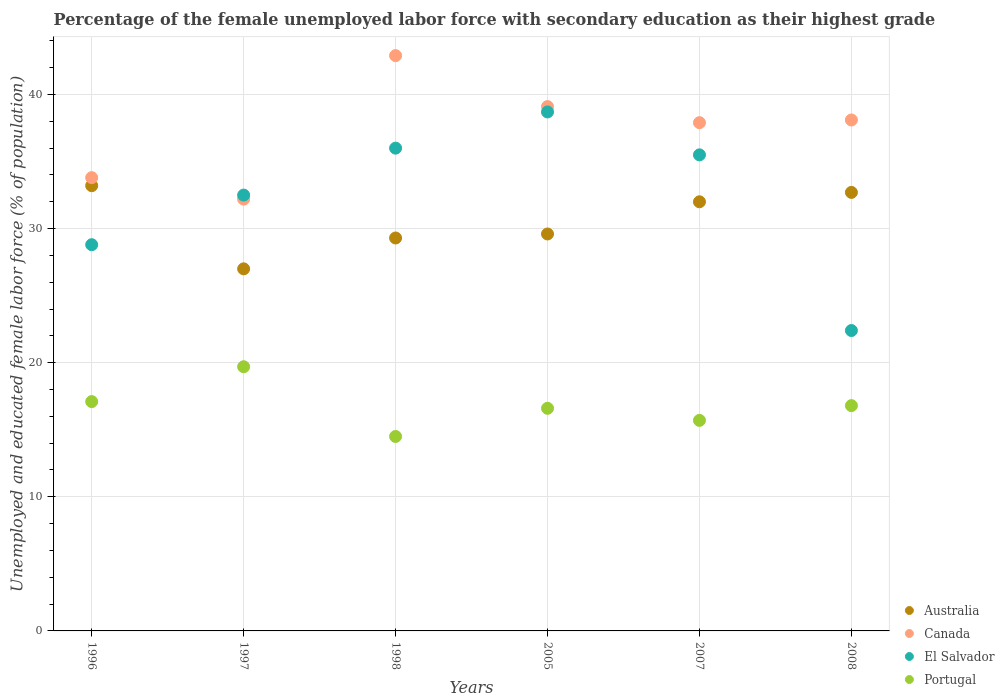How many different coloured dotlines are there?
Your answer should be compact. 4. What is the percentage of the unemployed female labor force with secondary education in Portugal in 2005?
Provide a short and direct response. 16.6. Across all years, what is the maximum percentage of the unemployed female labor force with secondary education in Canada?
Your response must be concise. 42.9. Across all years, what is the minimum percentage of the unemployed female labor force with secondary education in Portugal?
Keep it short and to the point. 14.5. In which year was the percentage of the unemployed female labor force with secondary education in El Salvador maximum?
Offer a very short reply. 2005. In which year was the percentage of the unemployed female labor force with secondary education in Australia minimum?
Ensure brevity in your answer.  1997. What is the total percentage of the unemployed female labor force with secondary education in Portugal in the graph?
Keep it short and to the point. 100.4. What is the difference between the percentage of the unemployed female labor force with secondary education in Australia in 1997 and that in 1998?
Offer a very short reply. -2.3. What is the difference between the percentage of the unemployed female labor force with secondary education in Canada in 1998 and the percentage of the unemployed female labor force with secondary education in Portugal in 2007?
Your answer should be compact. 27.2. What is the average percentage of the unemployed female labor force with secondary education in Australia per year?
Make the answer very short. 30.63. In the year 1996, what is the difference between the percentage of the unemployed female labor force with secondary education in Australia and percentage of the unemployed female labor force with secondary education in El Salvador?
Ensure brevity in your answer.  4.4. In how many years, is the percentage of the unemployed female labor force with secondary education in Australia greater than 14 %?
Keep it short and to the point. 6. What is the ratio of the percentage of the unemployed female labor force with secondary education in El Salvador in 1997 to that in 2005?
Give a very brief answer. 0.84. Is the percentage of the unemployed female labor force with secondary education in Australia in 1998 less than that in 2005?
Your response must be concise. Yes. What is the difference between the highest and the second highest percentage of the unemployed female labor force with secondary education in El Salvador?
Give a very brief answer. 2.7. What is the difference between the highest and the lowest percentage of the unemployed female labor force with secondary education in El Salvador?
Make the answer very short. 16.3. Is the sum of the percentage of the unemployed female labor force with secondary education in Canada in 1997 and 2007 greater than the maximum percentage of the unemployed female labor force with secondary education in Portugal across all years?
Your response must be concise. Yes. Is it the case that in every year, the sum of the percentage of the unemployed female labor force with secondary education in Portugal and percentage of the unemployed female labor force with secondary education in Australia  is greater than the sum of percentage of the unemployed female labor force with secondary education in Canada and percentage of the unemployed female labor force with secondary education in El Salvador?
Provide a short and direct response. No. Is it the case that in every year, the sum of the percentage of the unemployed female labor force with secondary education in Australia and percentage of the unemployed female labor force with secondary education in El Salvador  is greater than the percentage of the unemployed female labor force with secondary education in Canada?
Make the answer very short. Yes. What is the difference between two consecutive major ticks on the Y-axis?
Provide a short and direct response. 10. Does the graph contain any zero values?
Your answer should be compact. No. Does the graph contain grids?
Provide a succinct answer. Yes. Where does the legend appear in the graph?
Your answer should be compact. Bottom right. How many legend labels are there?
Your answer should be compact. 4. What is the title of the graph?
Keep it short and to the point. Percentage of the female unemployed labor force with secondary education as their highest grade. Does "Faeroe Islands" appear as one of the legend labels in the graph?
Keep it short and to the point. No. What is the label or title of the X-axis?
Your answer should be very brief. Years. What is the label or title of the Y-axis?
Your answer should be very brief. Unemployed and educated female labor force (% of population). What is the Unemployed and educated female labor force (% of population) in Australia in 1996?
Your answer should be compact. 33.2. What is the Unemployed and educated female labor force (% of population) in Canada in 1996?
Offer a terse response. 33.8. What is the Unemployed and educated female labor force (% of population) in El Salvador in 1996?
Make the answer very short. 28.8. What is the Unemployed and educated female labor force (% of population) in Portugal in 1996?
Your answer should be very brief. 17.1. What is the Unemployed and educated female labor force (% of population) in Australia in 1997?
Offer a very short reply. 27. What is the Unemployed and educated female labor force (% of population) of Canada in 1997?
Your answer should be very brief. 32.2. What is the Unemployed and educated female labor force (% of population) in El Salvador in 1997?
Make the answer very short. 32.5. What is the Unemployed and educated female labor force (% of population) in Portugal in 1997?
Your response must be concise. 19.7. What is the Unemployed and educated female labor force (% of population) in Australia in 1998?
Provide a succinct answer. 29.3. What is the Unemployed and educated female labor force (% of population) of Canada in 1998?
Your answer should be very brief. 42.9. What is the Unemployed and educated female labor force (% of population) in El Salvador in 1998?
Offer a terse response. 36. What is the Unemployed and educated female labor force (% of population) in Australia in 2005?
Your answer should be very brief. 29.6. What is the Unemployed and educated female labor force (% of population) of Canada in 2005?
Keep it short and to the point. 39.1. What is the Unemployed and educated female labor force (% of population) in El Salvador in 2005?
Provide a short and direct response. 38.7. What is the Unemployed and educated female labor force (% of population) of Portugal in 2005?
Offer a very short reply. 16.6. What is the Unemployed and educated female labor force (% of population) in Canada in 2007?
Make the answer very short. 37.9. What is the Unemployed and educated female labor force (% of population) in El Salvador in 2007?
Your answer should be compact. 35.5. What is the Unemployed and educated female labor force (% of population) in Portugal in 2007?
Ensure brevity in your answer.  15.7. What is the Unemployed and educated female labor force (% of population) of Australia in 2008?
Your answer should be compact. 32.7. What is the Unemployed and educated female labor force (% of population) in Canada in 2008?
Make the answer very short. 38.1. What is the Unemployed and educated female labor force (% of population) in El Salvador in 2008?
Keep it short and to the point. 22.4. What is the Unemployed and educated female labor force (% of population) in Portugal in 2008?
Give a very brief answer. 16.8. Across all years, what is the maximum Unemployed and educated female labor force (% of population) of Australia?
Your response must be concise. 33.2. Across all years, what is the maximum Unemployed and educated female labor force (% of population) in Canada?
Offer a very short reply. 42.9. Across all years, what is the maximum Unemployed and educated female labor force (% of population) in El Salvador?
Ensure brevity in your answer.  38.7. Across all years, what is the maximum Unemployed and educated female labor force (% of population) of Portugal?
Your answer should be compact. 19.7. Across all years, what is the minimum Unemployed and educated female labor force (% of population) in Australia?
Offer a very short reply. 27. Across all years, what is the minimum Unemployed and educated female labor force (% of population) of Canada?
Your response must be concise. 32.2. Across all years, what is the minimum Unemployed and educated female labor force (% of population) of El Salvador?
Your response must be concise. 22.4. What is the total Unemployed and educated female labor force (% of population) of Australia in the graph?
Ensure brevity in your answer.  183.8. What is the total Unemployed and educated female labor force (% of population) of Canada in the graph?
Your answer should be very brief. 224. What is the total Unemployed and educated female labor force (% of population) of El Salvador in the graph?
Make the answer very short. 193.9. What is the total Unemployed and educated female labor force (% of population) in Portugal in the graph?
Provide a succinct answer. 100.4. What is the difference between the Unemployed and educated female labor force (% of population) of Australia in 1996 and that in 1997?
Offer a terse response. 6.2. What is the difference between the Unemployed and educated female labor force (% of population) in El Salvador in 1996 and that in 1997?
Your response must be concise. -3.7. What is the difference between the Unemployed and educated female labor force (% of population) in Portugal in 1996 and that in 1997?
Make the answer very short. -2.6. What is the difference between the Unemployed and educated female labor force (% of population) of Canada in 1996 and that in 1998?
Keep it short and to the point. -9.1. What is the difference between the Unemployed and educated female labor force (% of population) of El Salvador in 1996 and that in 1998?
Provide a succinct answer. -7.2. What is the difference between the Unemployed and educated female labor force (% of population) of Australia in 1996 and that in 2005?
Keep it short and to the point. 3.6. What is the difference between the Unemployed and educated female labor force (% of population) in El Salvador in 1996 and that in 2005?
Give a very brief answer. -9.9. What is the difference between the Unemployed and educated female labor force (% of population) of Australia in 1996 and that in 2007?
Offer a terse response. 1.2. What is the difference between the Unemployed and educated female labor force (% of population) in Canada in 1996 and that in 2007?
Offer a very short reply. -4.1. What is the difference between the Unemployed and educated female labor force (% of population) of El Salvador in 1996 and that in 2007?
Your response must be concise. -6.7. What is the difference between the Unemployed and educated female labor force (% of population) of Australia in 1996 and that in 2008?
Your response must be concise. 0.5. What is the difference between the Unemployed and educated female labor force (% of population) of Canada in 1996 and that in 2008?
Your answer should be very brief. -4.3. What is the difference between the Unemployed and educated female labor force (% of population) in Australia in 1997 and that in 1998?
Your answer should be very brief. -2.3. What is the difference between the Unemployed and educated female labor force (% of population) of Canada in 1997 and that in 1998?
Your answer should be very brief. -10.7. What is the difference between the Unemployed and educated female labor force (% of population) of Australia in 1997 and that in 2005?
Keep it short and to the point. -2.6. What is the difference between the Unemployed and educated female labor force (% of population) of Canada in 1997 and that in 2005?
Ensure brevity in your answer.  -6.9. What is the difference between the Unemployed and educated female labor force (% of population) of Australia in 1997 and that in 2007?
Make the answer very short. -5. What is the difference between the Unemployed and educated female labor force (% of population) of Canada in 1997 and that in 2007?
Make the answer very short. -5.7. What is the difference between the Unemployed and educated female labor force (% of population) of Portugal in 1997 and that in 2007?
Keep it short and to the point. 4. What is the difference between the Unemployed and educated female labor force (% of population) in El Salvador in 1997 and that in 2008?
Your answer should be very brief. 10.1. What is the difference between the Unemployed and educated female labor force (% of population) of Canada in 1998 and that in 2005?
Keep it short and to the point. 3.8. What is the difference between the Unemployed and educated female labor force (% of population) of El Salvador in 1998 and that in 2005?
Ensure brevity in your answer.  -2.7. What is the difference between the Unemployed and educated female labor force (% of population) of Portugal in 1998 and that in 2005?
Your response must be concise. -2.1. What is the difference between the Unemployed and educated female labor force (% of population) of Australia in 1998 and that in 2008?
Keep it short and to the point. -3.4. What is the difference between the Unemployed and educated female labor force (% of population) in Portugal in 1998 and that in 2008?
Make the answer very short. -2.3. What is the difference between the Unemployed and educated female labor force (% of population) in Australia in 2005 and that in 2007?
Your answer should be very brief. -2.4. What is the difference between the Unemployed and educated female labor force (% of population) of El Salvador in 2005 and that in 2007?
Give a very brief answer. 3.2. What is the difference between the Unemployed and educated female labor force (% of population) in Australia in 2005 and that in 2008?
Your answer should be compact. -3.1. What is the difference between the Unemployed and educated female labor force (% of population) of Canada in 2005 and that in 2008?
Keep it short and to the point. 1. What is the difference between the Unemployed and educated female labor force (% of population) of El Salvador in 2005 and that in 2008?
Make the answer very short. 16.3. What is the difference between the Unemployed and educated female labor force (% of population) of Australia in 2007 and that in 2008?
Provide a short and direct response. -0.7. What is the difference between the Unemployed and educated female labor force (% of population) of Australia in 1996 and the Unemployed and educated female labor force (% of population) of Canada in 1997?
Ensure brevity in your answer.  1. What is the difference between the Unemployed and educated female labor force (% of population) in Australia in 1996 and the Unemployed and educated female labor force (% of population) in El Salvador in 1997?
Provide a short and direct response. 0.7. What is the difference between the Unemployed and educated female labor force (% of population) in Australia in 1996 and the Unemployed and educated female labor force (% of population) in Portugal in 1997?
Provide a succinct answer. 13.5. What is the difference between the Unemployed and educated female labor force (% of population) of Canada in 1996 and the Unemployed and educated female labor force (% of population) of El Salvador in 1997?
Offer a terse response. 1.3. What is the difference between the Unemployed and educated female labor force (% of population) of Canada in 1996 and the Unemployed and educated female labor force (% of population) of Portugal in 1997?
Give a very brief answer. 14.1. What is the difference between the Unemployed and educated female labor force (% of population) of Australia in 1996 and the Unemployed and educated female labor force (% of population) of Canada in 1998?
Provide a short and direct response. -9.7. What is the difference between the Unemployed and educated female labor force (% of population) of Australia in 1996 and the Unemployed and educated female labor force (% of population) of El Salvador in 1998?
Give a very brief answer. -2.8. What is the difference between the Unemployed and educated female labor force (% of population) in Canada in 1996 and the Unemployed and educated female labor force (% of population) in El Salvador in 1998?
Provide a short and direct response. -2.2. What is the difference between the Unemployed and educated female labor force (% of population) in Canada in 1996 and the Unemployed and educated female labor force (% of population) in Portugal in 1998?
Provide a short and direct response. 19.3. What is the difference between the Unemployed and educated female labor force (% of population) in Australia in 1996 and the Unemployed and educated female labor force (% of population) in Canada in 2005?
Offer a terse response. -5.9. What is the difference between the Unemployed and educated female labor force (% of population) in El Salvador in 1996 and the Unemployed and educated female labor force (% of population) in Portugal in 2005?
Ensure brevity in your answer.  12.2. What is the difference between the Unemployed and educated female labor force (% of population) of Australia in 1996 and the Unemployed and educated female labor force (% of population) of Canada in 2007?
Your answer should be compact. -4.7. What is the difference between the Unemployed and educated female labor force (% of population) in Canada in 1996 and the Unemployed and educated female labor force (% of population) in El Salvador in 2007?
Provide a short and direct response. -1.7. What is the difference between the Unemployed and educated female labor force (% of population) of Canada in 1996 and the Unemployed and educated female labor force (% of population) of Portugal in 2007?
Provide a succinct answer. 18.1. What is the difference between the Unemployed and educated female labor force (% of population) of Australia in 1996 and the Unemployed and educated female labor force (% of population) of Canada in 2008?
Offer a very short reply. -4.9. What is the difference between the Unemployed and educated female labor force (% of population) in Australia in 1996 and the Unemployed and educated female labor force (% of population) in Portugal in 2008?
Your response must be concise. 16.4. What is the difference between the Unemployed and educated female labor force (% of population) of Canada in 1996 and the Unemployed and educated female labor force (% of population) of El Salvador in 2008?
Your answer should be very brief. 11.4. What is the difference between the Unemployed and educated female labor force (% of population) of Canada in 1996 and the Unemployed and educated female labor force (% of population) of Portugal in 2008?
Offer a terse response. 17. What is the difference between the Unemployed and educated female labor force (% of population) of Australia in 1997 and the Unemployed and educated female labor force (% of population) of Canada in 1998?
Provide a short and direct response. -15.9. What is the difference between the Unemployed and educated female labor force (% of population) of Canada in 1997 and the Unemployed and educated female labor force (% of population) of El Salvador in 1998?
Provide a succinct answer. -3.8. What is the difference between the Unemployed and educated female labor force (% of population) of Canada in 1997 and the Unemployed and educated female labor force (% of population) of Portugal in 1998?
Provide a short and direct response. 17.7. What is the difference between the Unemployed and educated female labor force (% of population) of Australia in 1997 and the Unemployed and educated female labor force (% of population) of Canada in 2005?
Keep it short and to the point. -12.1. What is the difference between the Unemployed and educated female labor force (% of population) of Australia in 1997 and the Unemployed and educated female labor force (% of population) of Portugal in 2005?
Keep it short and to the point. 10.4. What is the difference between the Unemployed and educated female labor force (% of population) of El Salvador in 1997 and the Unemployed and educated female labor force (% of population) of Portugal in 2005?
Provide a succinct answer. 15.9. What is the difference between the Unemployed and educated female labor force (% of population) of Australia in 1997 and the Unemployed and educated female labor force (% of population) of Portugal in 2007?
Your answer should be compact. 11.3. What is the difference between the Unemployed and educated female labor force (% of population) in Canada in 1997 and the Unemployed and educated female labor force (% of population) in El Salvador in 2007?
Provide a short and direct response. -3.3. What is the difference between the Unemployed and educated female labor force (% of population) in Canada in 1997 and the Unemployed and educated female labor force (% of population) in Portugal in 2007?
Keep it short and to the point. 16.5. What is the difference between the Unemployed and educated female labor force (% of population) of El Salvador in 1997 and the Unemployed and educated female labor force (% of population) of Portugal in 2007?
Your answer should be very brief. 16.8. What is the difference between the Unemployed and educated female labor force (% of population) of Australia in 1997 and the Unemployed and educated female labor force (% of population) of El Salvador in 2008?
Provide a succinct answer. 4.6. What is the difference between the Unemployed and educated female labor force (% of population) in Canada in 1997 and the Unemployed and educated female labor force (% of population) in El Salvador in 2008?
Offer a very short reply. 9.8. What is the difference between the Unemployed and educated female labor force (% of population) in Canada in 1997 and the Unemployed and educated female labor force (% of population) in Portugal in 2008?
Give a very brief answer. 15.4. What is the difference between the Unemployed and educated female labor force (% of population) in El Salvador in 1997 and the Unemployed and educated female labor force (% of population) in Portugal in 2008?
Offer a terse response. 15.7. What is the difference between the Unemployed and educated female labor force (% of population) in Australia in 1998 and the Unemployed and educated female labor force (% of population) in Portugal in 2005?
Keep it short and to the point. 12.7. What is the difference between the Unemployed and educated female labor force (% of population) in Canada in 1998 and the Unemployed and educated female labor force (% of population) in Portugal in 2005?
Your answer should be very brief. 26.3. What is the difference between the Unemployed and educated female labor force (% of population) in El Salvador in 1998 and the Unemployed and educated female labor force (% of population) in Portugal in 2005?
Your response must be concise. 19.4. What is the difference between the Unemployed and educated female labor force (% of population) in Australia in 1998 and the Unemployed and educated female labor force (% of population) in Canada in 2007?
Offer a very short reply. -8.6. What is the difference between the Unemployed and educated female labor force (% of population) in Canada in 1998 and the Unemployed and educated female labor force (% of population) in El Salvador in 2007?
Offer a terse response. 7.4. What is the difference between the Unemployed and educated female labor force (% of population) of Canada in 1998 and the Unemployed and educated female labor force (% of population) of Portugal in 2007?
Ensure brevity in your answer.  27.2. What is the difference between the Unemployed and educated female labor force (% of population) in El Salvador in 1998 and the Unemployed and educated female labor force (% of population) in Portugal in 2007?
Make the answer very short. 20.3. What is the difference between the Unemployed and educated female labor force (% of population) in Canada in 1998 and the Unemployed and educated female labor force (% of population) in Portugal in 2008?
Provide a succinct answer. 26.1. What is the difference between the Unemployed and educated female labor force (% of population) in El Salvador in 1998 and the Unemployed and educated female labor force (% of population) in Portugal in 2008?
Provide a succinct answer. 19.2. What is the difference between the Unemployed and educated female labor force (% of population) in Australia in 2005 and the Unemployed and educated female labor force (% of population) in El Salvador in 2007?
Keep it short and to the point. -5.9. What is the difference between the Unemployed and educated female labor force (% of population) of Canada in 2005 and the Unemployed and educated female labor force (% of population) of Portugal in 2007?
Offer a terse response. 23.4. What is the difference between the Unemployed and educated female labor force (% of population) of Australia in 2005 and the Unemployed and educated female labor force (% of population) of Canada in 2008?
Offer a terse response. -8.5. What is the difference between the Unemployed and educated female labor force (% of population) in Canada in 2005 and the Unemployed and educated female labor force (% of population) in El Salvador in 2008?
Provide a succinct answer. 16.7. What is the difference between the Unemployed and educated female labor force (% of population) in Canada in 2005 and the Unemployed and educated female labor force (% of population) in Portugal in 2008?
Ensure brevity in your answer.  22.3. What is the difference between the Unemployed and educated female labor force (% of population) of El Salvador in 2005 and the Unemployed and educated female labor force (% of population) of Portugal in 2008?
Provide a succinct answer. 21.9. What is the difference between the Unemployed and educated female labor force (% of population) of Australia in 2007 and the Unemployed and educated female labor force (% of population) of Portugal in 2008?
Make the answer very short. 15.2. What is the difference between the Unemployed and educated female labor force (% of population) of Canada in 2007 and the Unemployed and educated female labor force (% of population) of Portugal in 2008?
Your answer should be very brief. 21.1. What is the average Unemployed and educated female labor force (% of population) in Australia per year?
Your answer should be very brief. 30.63. What is the average Unemployed and educated female labor force (% of population) in Canada per year?
Offer a terse response. 37.33. What is the average Unemployed and educated female labor force (% of population) in El Salvador per year?
Offer a terse response. 32.32. What is the average Unemployed and educated female labor force (% of population) of Portugal per year?
Offer a very short reply. 16.73. In the year 1996, what is the difference between the Unemployed and educated female labor force (% of population) in Australia and Unemployed and educated female labor force (% of population) in Canada?
Keep it short and to the point. -0.6. In the year 1996, what is the difference between the Unemployed and educated female labor force (% of population) in El Salvador and Unemployed and educated female labor force (% of population) in Portugal?
Provide a succinct answer. 11.7. In the year 1997, what is the difference between the Unemployed and educated female labor force (% of population) of Australia and Unemployed and educated female labor force (% of population) of Canada?
Offer a very short reply. -5.2. In the year 1997, what is the difference between the Unemployed and educated female labor force (% of population) in Australia and Unemployed and educated female labor force (% of population) in Portugal?
Provide a succinct answer. 7.3. In the year 1997, what is the difference between the Unemployed and educated female labor force (% of population) in Canada and Unemployed and educated female labor force (% of population) in El Salvador?
Your answer should be compact. -0.3. In the year 1997, what is the difference between the Unemployed and educated female labor force (% of population) of Canada and Unemployed and educated female labor force (% of population) of Portugal?
Your response must be concise. 12.5. In the year 1998, what is the difference between the Unemployed and educated female labor force (% of population) of Australia and Unemployed and educated female labor force (% of population) of El Salvador?
Provide a short and direct response. -6.7. In the year 1998, what is the difference between the Unemployed and educated female labor force (% of population) of Canada and Unemployed and educated female labor force (% of population) of El Salvador?
Your response must be concise. 6.9. In the year 1998, what is the difference between the Unemployed and educated female labor force (% of population) in Canada and Unemployed and educated female labor force (% of population) in Portugal?
Offer a terse response. 28.4. In the year 2005, what is the difference between the Unemployed and educated female labor force (% of population) of Australia and Unemployed and educated female labor force (% of population) of Portugal?
Offer a terse response. 13. In the year 2005, what is the difference between the Unemployed and educated female labor force (% of population) of Canada and Unemployed and educated female labor force (% of population) of Portugal?
Your answer should be very brief. 22.5. In the year 2005, what is the difference between the Unemployed and educated female labor force (% of population) in El Salvador and Unemployed and educated female labor force (% of population) in Portugal?
Keep it short and to the point. 22.1. In the year 2007, what is the difference between the Unemployed and educated female labor force (% of population) of Australia and Unemployed and educated female labor force (% of population) of Canada?
Make the answer very short. -5.9. In the year 2007, what is the difference between the Unemployed and educated female labor force (% of population) in Canada and Unemployed and educated female labor force (% of population) in Portugal?
Your answer should be compact. 22.2. In the year 2007, what is the difference between the Unemployed and educated female labor force (% of population) of El Salvador and Unemployed and educated female labor force (% of population) of Portugal?
Provide a succinct answer. 19.8. In the year 2008, what is the difference between the Unemployed and educated female labor force (% of population) in Australia and Unemployed and educated female labor force (% of population) in Canada?
Your answer should be compact. -5.4. In the year 2008, what is the difference between the Unemployed and educated female labor force (% of population) in Australia and Unemployed and educated female labor force (% of population) in El Salvador?
Give a very brief answer. 10.3. In the year 2008, what is the difference between the Unemployed and educated female labor force (% of population) in Australia and Unemployed and educated female labor force (% of population) in Portugal?
Offer a very short reply. 15.9. In the year 2008, what is the difference between the Unemployed and educated female labor force (% of population) of Canada and Unemployed and educated female labor force (% of population) of El Salvador?
Your response must be concise. 15.7. In the year 2008, what is the difference between the Unemployed and educated female labor force (% of population) in Canada and Unemployed and educated female labor force (% of population) in Portugal?
Offer a very short reply. 21.3. In the year 2008, what is the difference between the Unemployed and educated female labor force (% of population) in El Salvador and Unemployed and educated female labor force (% of population) in Portugal?
Ensure brevity in your answer.  5.6. What is the ratio of the Unemployed and educated female labor force (% of population) in Australia in 1996 to that in 1997?
Your answer should be compact. 1.23. What is the ratio of the Unemployed and educated female labor force (% of population) of Canada in 1996 to that in 1997?
Keep it short and to the point. 1.05. What is the ratio of the Unemployed and educated female labor force (% of population) in El Salvador in 1996 to that in 1997?
Offer a very short reply. 0.89. What is the ratio of the Unemployed and educated female labor force (% of population) in Portugal in 1996 to that in 1997?
Your answer should be compact. 0.87. What is the ratio of the Unemployed and educated female labor force (% of population) in Australia in 1996 to that in 1998?
Provide a short and direct response. 1.13. What is the ratio of the Unemployed and educated female labor force (% of population) of Canada in 1996 to that in 1998?
Your answer should be very brief. 0.79. What is the ratio of the Unemployed and educated female labor force (% of population) in Portugal in 1996 to that in 1998?
Offer a very short reply. 1.18. What is the ratio of the Unemployed and educated female labor force (% of population) in Australia in 1996 to that in 2005?
Ensure brevity in your answer.  1.12. What is the ratio of the Unemployed and educated female labor force (% of population) in Canada in 1996 to that in 2005?
Make the answer very short. 0.86. What is the ratio of the Unemployed and educated female labor force (% of population) of El Salvador in 1996 to that in 2005?
Offer a very short reply. 0.74. What is the ratio of the Unemployed and educated female labor force (% of population) of Portugal in 1996 to that in 2005?
Offer a terse response. 1.03. What is the ratio of the Unemployed and educated female labor force (% of population) of Australia in 1996 to that in 2007?
Your answer should be very brief. 1.04. What is the ratio of the Unemployed and educated female labor force (% of population) in Canada in 1996 to that in 2007?
Offer a terse response. 0.89. What is the ratio of the Unemployed and educated female labor force (% of population) in El Salvador in 1996 to that in 2007?
Ensure brevity in your answer.  0.81. What is the ratio of the Unemployed and educated female labor force (% of population) in Portugal in 1996 to that in 2007?
Provide a short and direct response. 1.09. What is the ratio of the Unemployed and educated female labor force (% of population) of Australia in 1996 to that in 2008?
Your response must be concise. 1.02. What is the ratio of the Unemployed and educated female labor force (% of population) in Canada in 1996 to that in 2008?
Your answer should be very brief. 0.89. What is the ratio of the Unemployed and educated female labor force (% of population) of Portugal in 1996 to that in 2008?
Make the answer very short. 1.02. What is the ratio of the Unemployed and educated female labor force (% of population) of Australia in 1997 to that in 1998?
Your response must be concise. 0.92. What is the ratio of the Unemployed and educated female labor force (% of population) in Canada in 1997 to that in 1998?
Your response must be concise. 0.75. What is the ratio of the Unemployed and educated female labor force (% of population) in El Salvador in 1997 to that in 1998?
Your response must be concise. 0.9. What is the ratio of the Unemployed and educated female labor force (% of population) in Portugal in 1997 to that in 1998?
Keep it short and to the point. 1.36. What is the ratio of the Unemployed and educated female labor force (% of population) in Australia in 1997 to that in 2005?
Offer a terse response. 0.91. What is the ratio of the Unemployed and educated female labor force (% of population) of Canada in 1997 to that in 2005?
Offer a very short reply. 0.82. What is the ratio of the Unemployed and educated female labor force (% of population) of El Salvador in 1997 to that in 2005?
Give a very brief answer. 0.84. What is the ratio of the Unemployed and educated female labor force (% of population) in Portugal in 1997 to that in 2005?
Your answer should be very brief. 1.19. What is the ratio of the Unemployed and educated female labor force (% of population) of Australia in 1997 to that in 2007?
Provide a succinct answer. 0.84. What is the ratio of the Unemployed and educated female labor force (% of population) in Canada in 1997 to that in 2007?
Your answer should be very brief. 0.85. What is the ratio of the Unemployed and educated female labor force (% of population) in El Salvador in 1997 to that in 2007?
Ensure brevity in your answer.  0.92. What is the ratio of the Unemployed and educated female labor force (% of population) of Portugal in 1997 to that in 2007?
Make the answer very short. 1.25. What is the ratio of the Unemployed and educated female labor force (% of population) of Australia in 1997 to that in 2008?
Provide a short and direct response. 0.83. What is the ratio of the Unemployed and educated female labor force (% of population) in Canada in 1997 to that in 2008?
Your answer should be compact. 0.85. What is the ratio of the Unemployed and educated female labor force (% of population) of El Salvador in 1997 to that in 2008?
Your answer should be very brief. 1.45. What is the ratio of the Unemployed and educated female labor force (% of population) in Portugal in 1997 to that in 2008?
Keep it short and to the point. 1.17. What is the ratio of the Unemployed and educated female labor force (% of population) of Australia in 1998 to that in 2005?
Ensure brevity in your answer.  0.99. What is the ratio of the Unemployed and educated female labor force (% of population) of Canada in 1998 to that in 2005?
Keep it short and to the point. 1.1. What is the ratio of the Unemployed and educated female labor force (% of population) of El Salvador in 1998 to that in 2005?
Ensure brevity in your answer.  0.93. What is the ratio of the Unemployed and educated female labor force (% of population) in Portugal in 1998 to that in 2005?
Your answer should be compact. 0.87. What is the ratio of the Unemployed and educated female labor force (% of population) of Australia in 1998 to that in 2007?
Ensure brevity in your answer.  0.92. What is the ratio of the Unemployed and educated female labor force (% of population) of Canada in 1998 to that in 2007?
Ensure brevity in your answer.  1.13. What is the ratio of the Unemployed and educated female labor force (% of population) of El Salvador in 1998 to that in 2007?
Your answer should be compact. 1.01. What is the ratio of the Unemployed and educated female labor force (% of population) in Portugal in 1998 to that in 2007?
Make the answer very short. 0.92. What is the ratio of the Unemployed and educated female labor force (% of population) in Australia in 1998 to that in 2008?
Give a very brief answer. 0.9. What is the ratio of the Unemployed and educated female labor force (% of population) of Canada in 1998 to that in 2008?
Offer a terse response. 1.13. What is the ratio of the Unemployed and educated female labor force (% of population) of El Salvador in 1998 to that in 2008?
Your answer should be compact. 1.61. What is the ratio of the Unemployed and educated female labor force (% of population) in Portugal in 1998 to that in 2008?
Your answer should be very brief. 0.86. What is the ratio of the Unemployed and educated female labor force (% of population) of Australia in 2005 to that in 2007?
Your answer should be very brief. 0.93. What is the ratio of the Unemployed and educated female labor force (% of population) in Canada in 2005 to that in 2007?
Offer a very short reply. 1.03. What is the ratio of the Unemployed and educated female labor force (% of population) in El Salvador in 2005 to that in 2007?
Ensure brevity in your answer.  1.09. What is the ratio of the Unemployed and educated female labor force (% of population) of Portugal in 2005 to that in 2007?
Your response must be concise. 1.06. What is the ratio of the Unemployed and educated female labor force (% of population) in Australia in 2005 to that in 2008?
Ensure brevity in your answer.  0.91. What is the ratio of the Unemployed and educated female labor force (% of population) of Canada in 2005 to that in 2008?
Your answer should be very brief. 1.03. What is the ratio of the Unemployed and educated female labor force (% of population) of El Salvador in 2005 to that in 2008?
Ensure brevity in your answer.  1.73. What is the ratio of the Unemployed and educated female labor force (% of population) of Portugal in 2005 to that in 2008?
Offer a terse response. 0.99. What is the ratio of the Unemployed and educated female labor force (% of population) in Australia in 2007 to that in 2008?
Ensure brevity in your answer.  0.98. What is the ratio of the Unemployed and educated female labor force (% of population) of El Salvador in 2007 to that in 2008?
Provide a short and direct response. 1.58. What is the ratio of the Unemployed and educated female labor force (% of population) in Portugal in 2007 to that in 2008?
Offer a terse response. 0.93. What is the difference between the highest and the second highest Unemployed and educated female labor force (% of population) in Canada?
Provide a short and direct response. 3.8. What is the difference between the highest and the second highest Unemployed and educated female labor force (% of population) in El Salvador?
Provide a short and direct response. 2.7. What is the difference between the highest and the second highest Unemployed and educated female labor force (% of population) in Portugal?
Your response must be concise. 2.6. What is the difference between the highest and the lowest Unemployed and educated female labor force (% of population) in Australia?
Ensure brevity in your answer.  6.2. What is the difference between the highest and the lowest Unemployed and educated female labor force (% of population) in Portugal?
Your answer should be very brief. 5.2. 